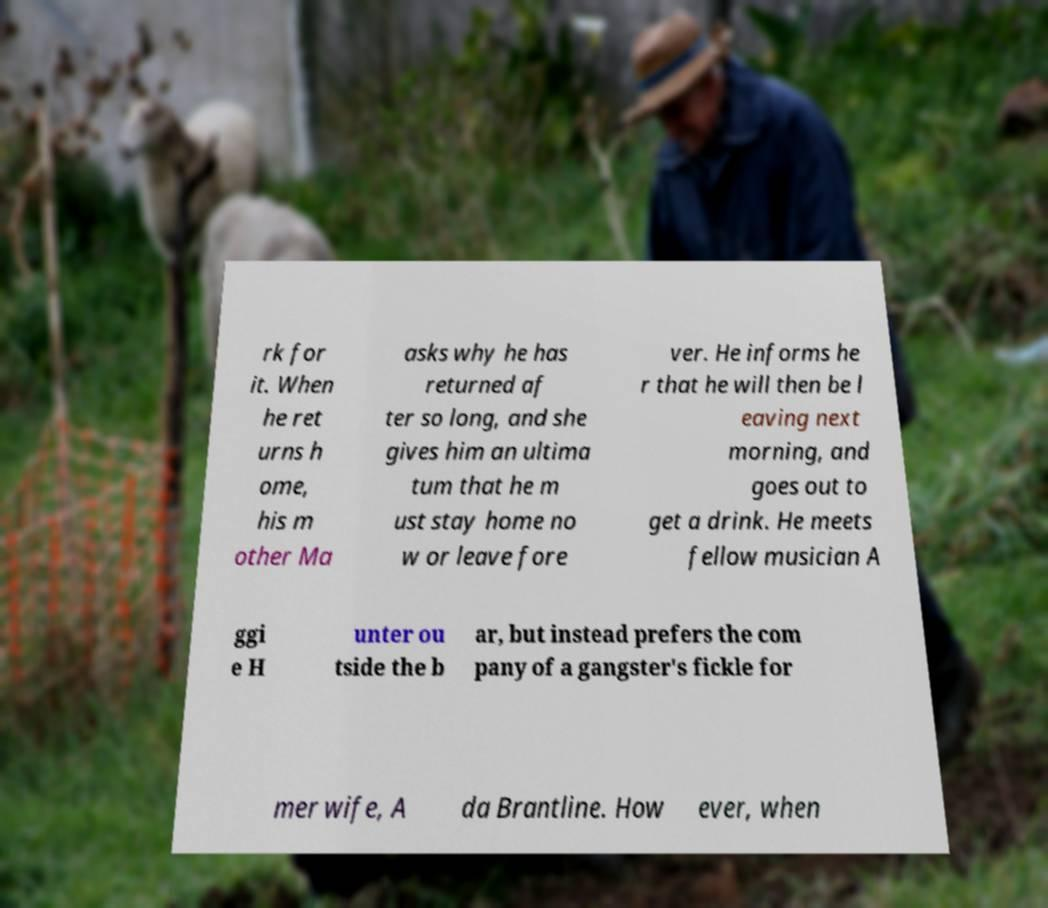Please read and relay the text visible in this image. What does it say? rk for it. When he ret urns h ome, his m other Ma asks why he has returned af ter so long, and she gives him an ultima tum that he m ust stay home no w or leave fore ver. He informs he r that he will then be l eaving next morning, and goes out to get a drink. He meets fellow musician A ggi e H unter ou tside the b ar, but instead prefers the com pany of a gangster's fickle for mer wife, A da Brantline. How ever, when 